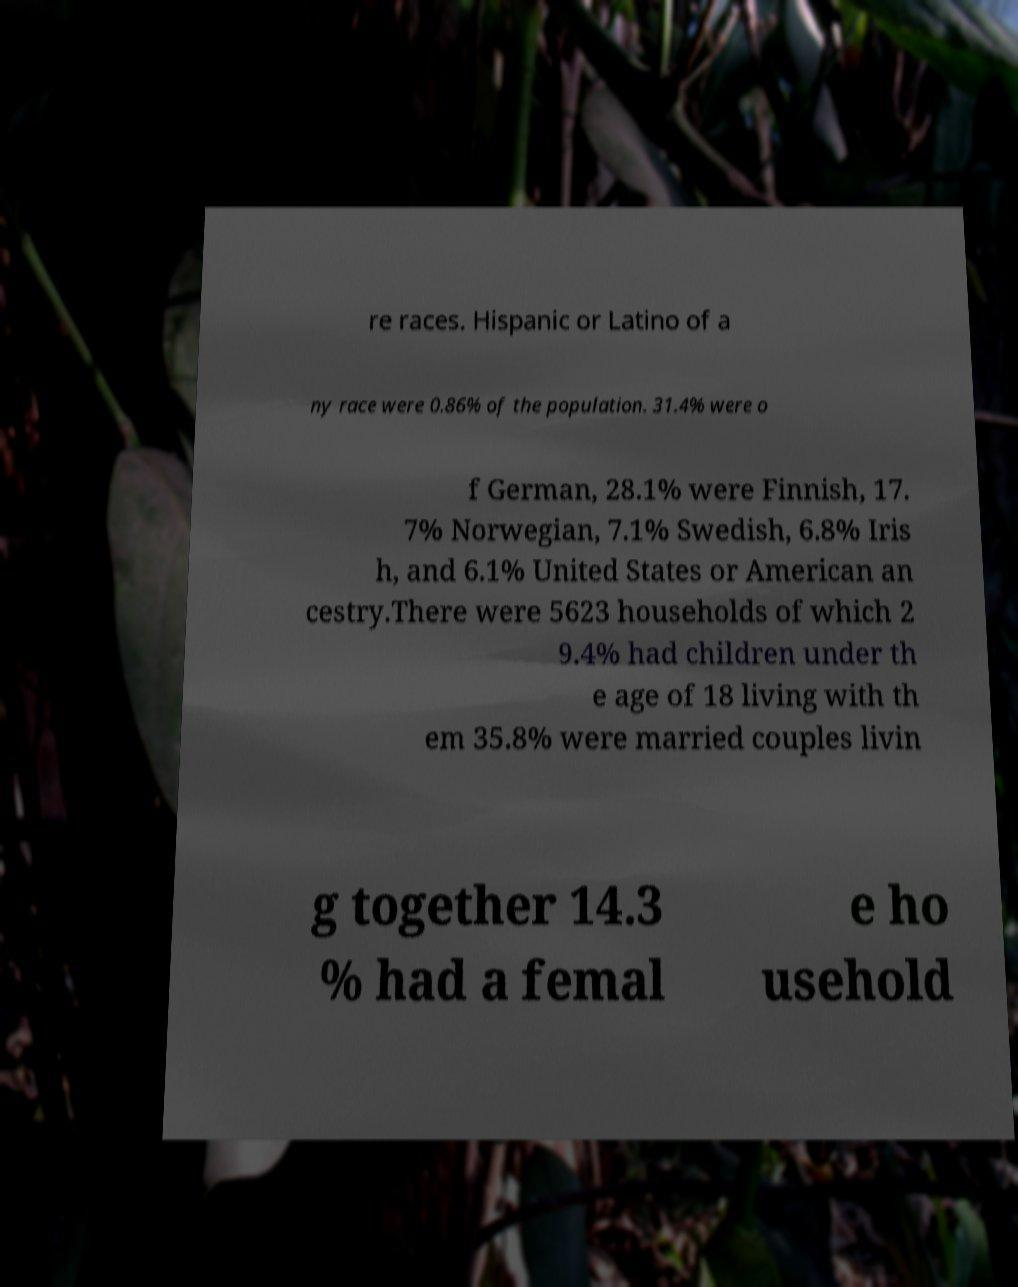Please read and relay the text visible in this image. What does it say? re races. Hispanic or Latino of a ny race were 0.86% of the population. 31.4% were o f German, 28.1% were Finnish, 17. 7% Norwegian, 7.1% Swedish, 6.8% Iris h, and 6.1% United States or American an cestry.There were 5623 households of which 2 9.4% had children under th e age of 18 living with th em 35.8% were married couples livin g together 14.3 % had a femal e ho usehold 